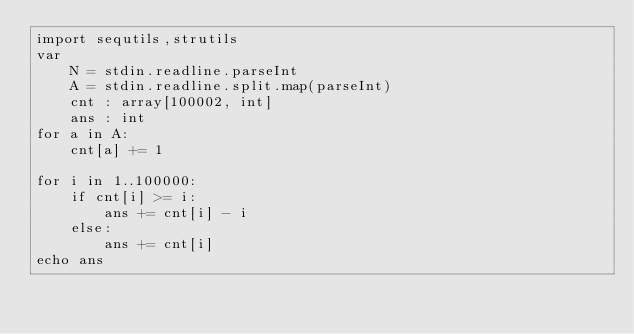Convert code to text. <code><loc_0><loc_0><loc_500><loc_500><_Nim_>import sequtils,strutils
var
    N = stdin.readline.parseInt
    A = stdin.readline.split.map(parseInt)
    cnt : array[100002, int]
    ans : int
for a in A:
    cnt[a] += 1

for i in 1..100000:
    if cnt[i] >= i:
        ans += cnt[i] - i
    else:
        ans += cnt[i]
echo ans</code> 